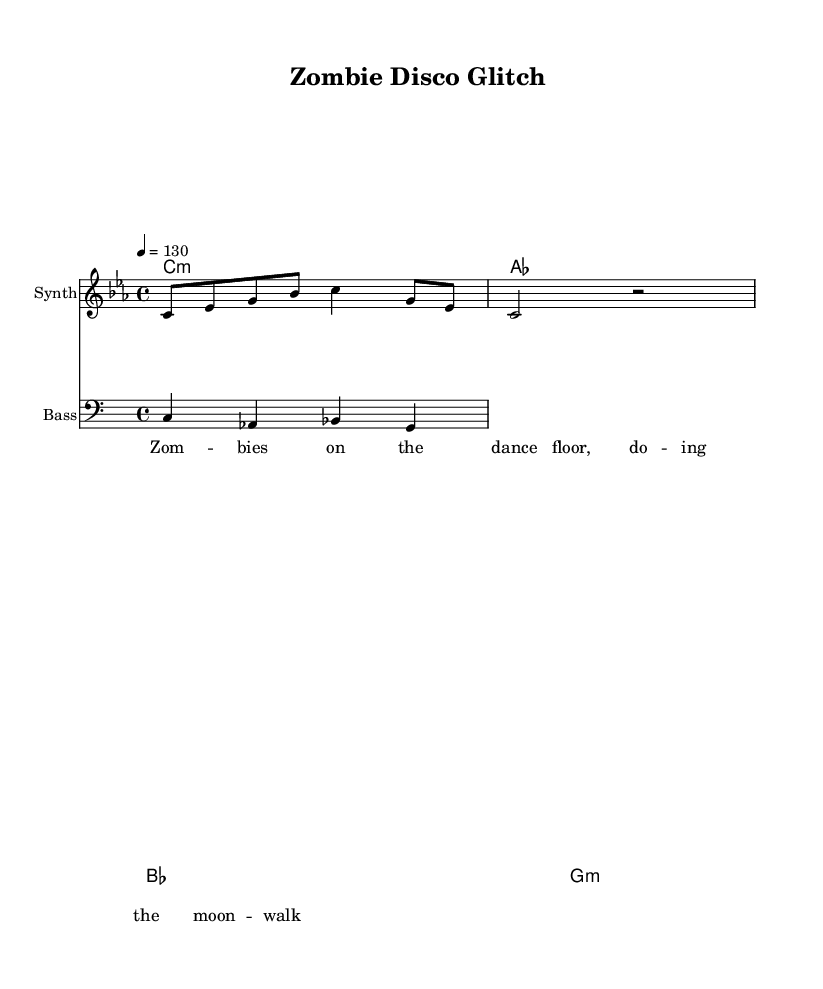What is the key signature of this music? The key signature is indicated by the clef and the notes present. In this case, it is C minor, which has three flats.
Answer: C minor What is the time signature of this music? The time signature is explicitly indicated at the beginning of the score, shown as 4/4, meaning there are four beats per measure.
Answer: 4/4 What is the tempo marking provided in the sheet music? The tempo is indicated as a number in beats per minute, shown as 130, meaning the piece should be played at 130 beats per minute.
Answer: 130 What type of instrument is specified for the melody? The score specifies "Synth" as the instrument name for the melody staff, indicating it should be played with a synthesizer sound.
Answer: Synth How many measures are in the melody? The melody consists of two measures of music provided above, identifiable by the vertical lines separating them.
Answer: 2 What genre does this piece represent? The title "Zombie Disco Glitch" along with the comedic horror-themed lyrics strongly suggests that it falls under the glitch-hop electronic genre.
Answer: Glitch-hop What is the lyrical theme of the verse? The lyrics discuss "Zombies on the dance floor," indicating a humorous horror theme focused on zombies and dance.
Answer: Zombies on the dance floor 